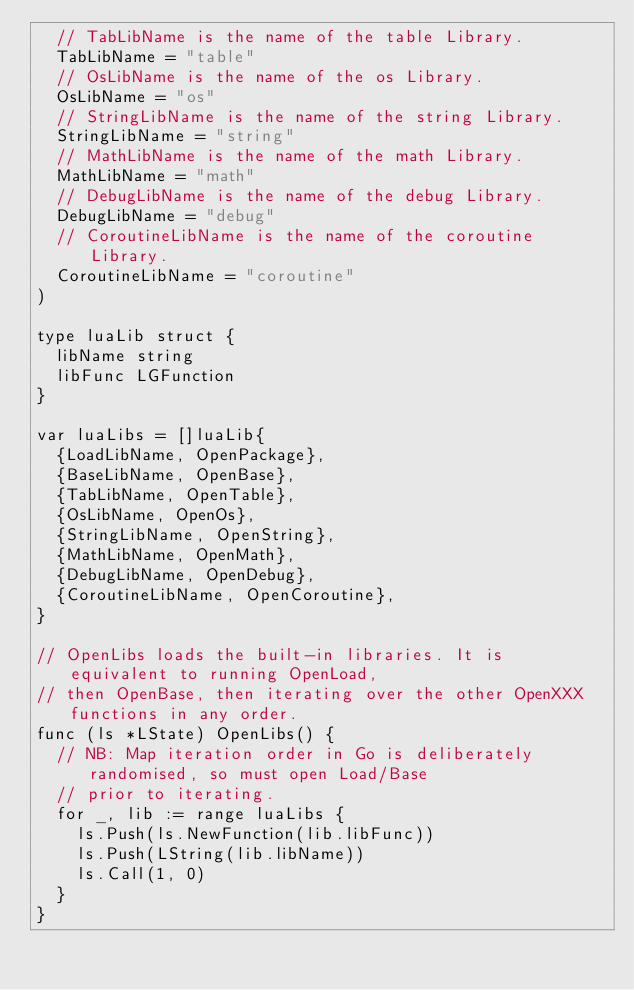Convert code to text. <code><loc_0><loc_0><loc_500><loc_500><_Go_>	// TabLibName is the name of the table Library.
	TabLibName = "table"
	// OsLibName is the name of the os Library.
	OsLibName = "os"
	// StringLibName is the name of the string Library.
	StringLibName = "string"
	// MathLibName is the name of the math Library.
	MathLibName = "math"
	// DebugLibName is the name of the debug Library.
	DebugLibName = "debug"
	// CoroutineLibName is the name of the coroutine Library.
	CoroutineLibName = "coroutine"
)

type luaLib struct {
	libName string
	libFunc LGFunction
}

var luaLibs = []luaLib{
	{LoadLibName, OpenPackage},
	{BaseLibName, OpenBase},
	{TabLibName, OpenTable},
	{OsLibName, OpenOs},
	{StringLibName, OpenString},
	{MathLibName, OpenMath},
	{DebugLibName, OpenDebug},
	{CoroutineLibName, OpenCoroutine},
}

// OpenLibs loads the built-in libraries. It is equivalent to running OpenLoad,
// then OpenBase, then iterating over the other OpenXXX functions in any order.
func (ls *LState) OpenLibs() {
	// NB: Map iteration order in Go is deliberately randomised, so must open Load/Base
	// prior to iterating.
	for _, lib := range luaLibs {
		ls.Push(ls.NewFunction(lib.libFunc))
		ls.Push(LString(lib.libName))
		ls.Call(1, 0)
	}
}
</code> 